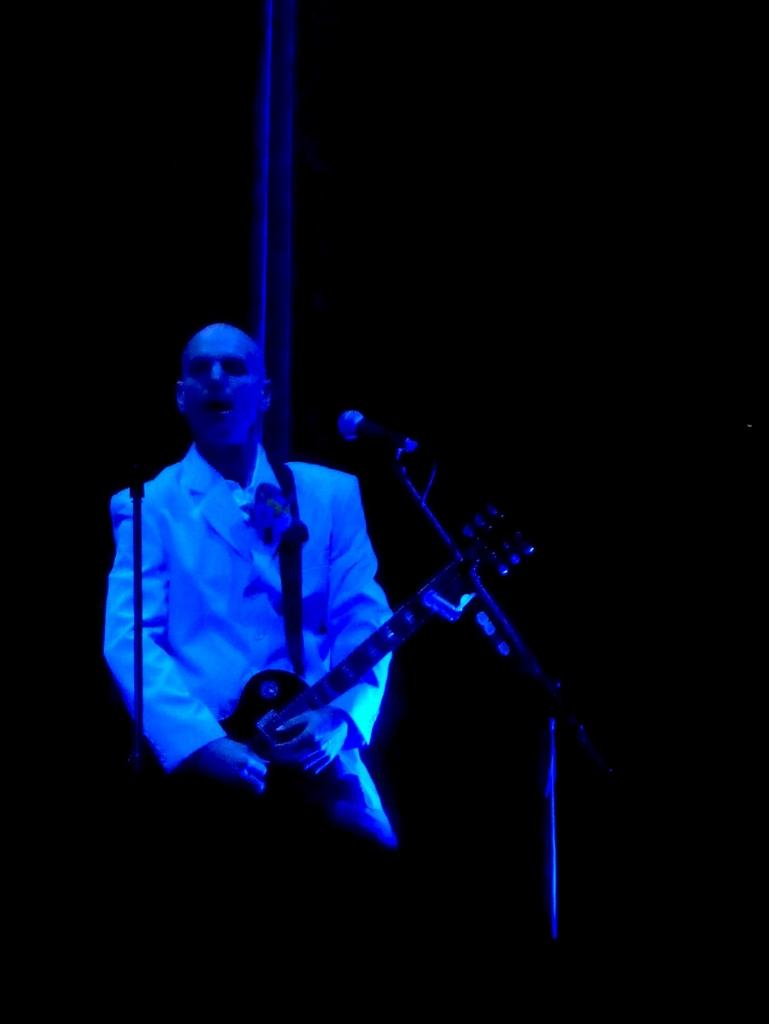What is the person in the image doing? The person is holding a guitar. What object is present in the image that is typically used for amplifying sound? There is a microphone with a stand in the image. What type of shoe is the fowl wearing in the image? There is no fowl or shoe present in the image. 